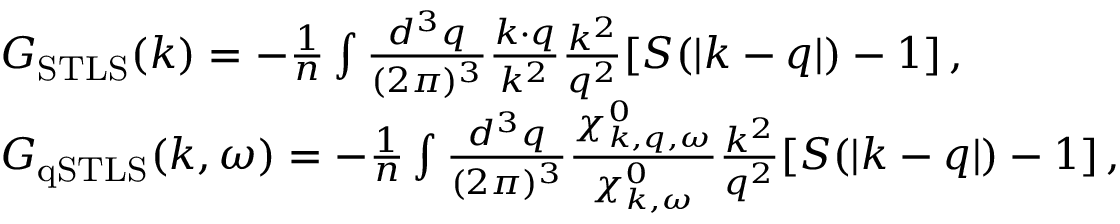Convert formula to latex. <formula><loc_0><loc_0><loc_500><loc_500>\begin{array} { r l } & { G _ { S T L S } ( k ) = - \frac { 1 } { n } \int \frac { d ^ { 3 } q } { ( 2 \pi ) ^ { 3 } } \frac { k \cdot q } { k ^ { 2 } } \frac { k ^ { 2 } } { q ^ { 2 } } [ S ( | k - q | ) - 1 ] \, , } \\ & { G _ { q S T L S } ( k , \omega ) = - \frac { 1 } { n } \int \frac { d ^ { 3 } q } { ( 2 \pi ) ^ { 3 } } \frac { \chi _ { k , q , \omega } ^ { 0 } } { \chi _ { k , \omega } ^ { 0 } } \frac { k ^ { 2 } } { q ^ { 2 } } [ S ( | k - q | ) - 1 ] \, , } \end{array}</formula> 